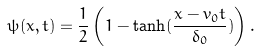<formula> <loc_0><loc_0><loc_500><loc_500>\psi ( x , t ) = \frac { 1 } { 2 } \left ( 1 - \tanh ( \frac { x - v _ { 0 } t } { \delta _ { 0 } } ) \right ) .</formula> 